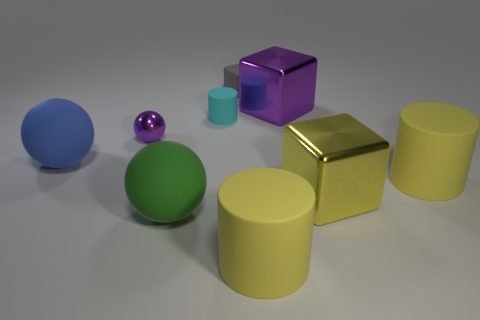Subtract 1 spheres. How many spheres are left? 2 Add 1 small red matte cylinders. How many objects exist? 10 Subtract all cylinders. How many objects are left? 6 Subtract all small metallic balls. Subtract all big yellow matte cylinders. How many objects are left? 6 Add 1 yellow cylinders. How many yellow cylinders are left? 3 Add 1 purple things. How many purple things exist? 3 Subtract 1 blue spheres. How many objects are left? 8 